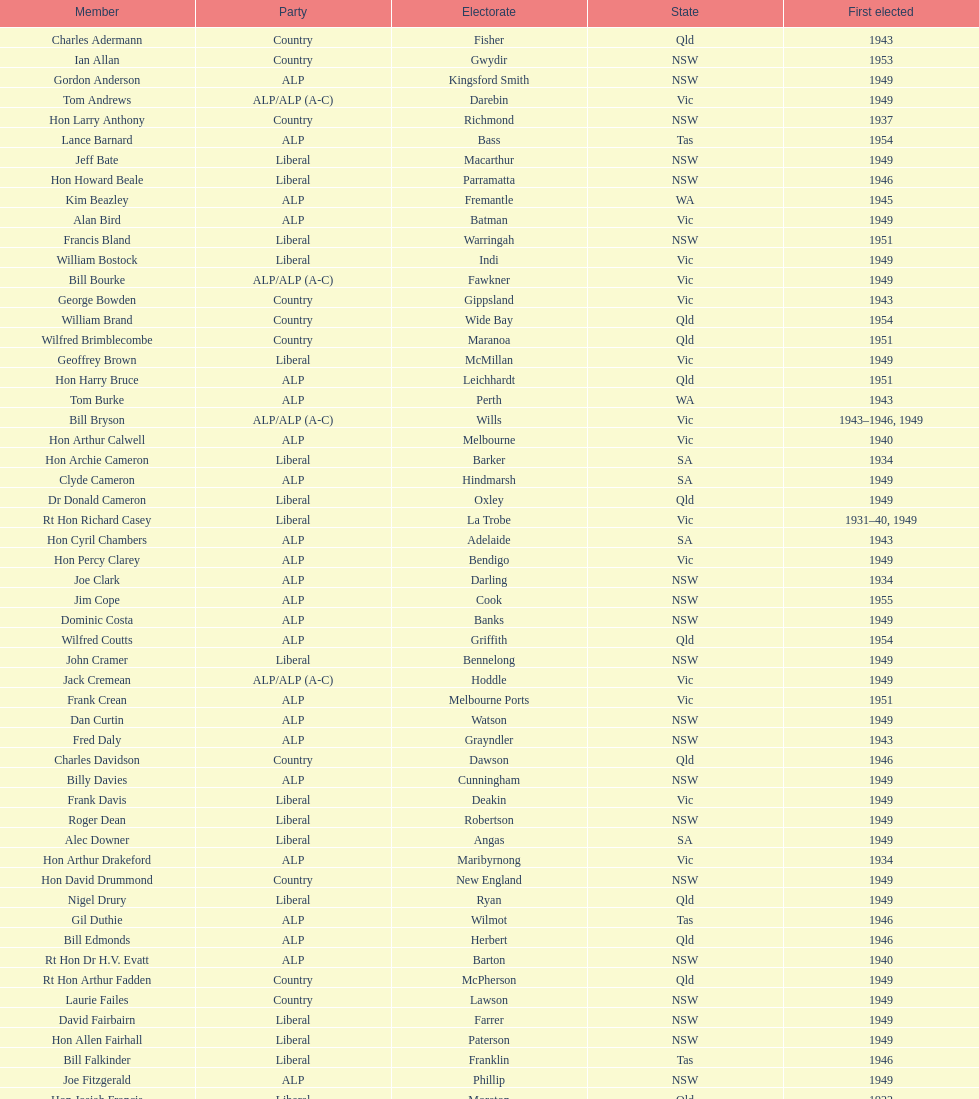Which party was chosen the least? Country. Give me the full table as a dictionary. {'header': ['Member', 'Party', 'Electorate', 'State', 'First elected'], 'rows': [['Charles Adermann', 'Country', 'Fisher', 'Qld', '1943'], ['Ian Allan', 'Country', 'Gwydir', 'NSW', '1953'], ['Gordon Anderson', 'ALP', 'Kingsford Smith', 'NSW', '1949'], ['Tom Andrews', 'ALP/ALP (A-C)', 'Darebin', 'Vic', '1949'], ['Hon Larry Anthony', 'Country', 'Richmond', 'NSW', '1937'], ['Lance Barnard', 'ALP', 'Bass', 'Tas', '1954'], ['Jeff Bate', 'Liberal', 'Macarthur', 'NSW', '1949'], ['Hon Howard Beale', 'Liberal', 'Parramatta', 'NSW', '1946'], ['Kim Beazley', 'ALP', 'Fremantle', 'WA', '1945'], ['Alan Bird', 'ALP', 'Batman', 'Vic', '1949'], ['Francis Bland', 'Liberal', 'Warringah', 'NSW', '1951'], ['William Bostock', 'Liberal', 'Indi', 'Vic', '1949'], ['Bill Bourke', 'ALP/ALP (A-C)', 'Fawkner', 'Vic', '1949'], ['George Bowden', 'Country', 'Gippsland', 'Vic', '1943'], ['William Brand', 'Country', 'Wide Bay', 'Qld', '1954'], ['Wilfred Brimblecombe', 'Country', 'Maranoa', 'Qld', '1951'], ['Geoffrey Brown', 'Liberal', 'McMillan', 'Vic', '1949'], ['Hon Harry Bruce', 'ALP', 'Leichhardt', 'Qld', '1951'], ['Tom Burke', 'ALP', 'Perth', 'WA', '1943'], ['Bill Bryson', 'ALP/ALP (A-C)', 'Wills', 'Vic', '1943–1946, 1949'], ['Hon Arthur Calwell', 'ALP', 'Melbourne', 'Vic', '1940'], ['Hon Archie Cameron', 'Liberal', 'Barker', 'SA', '1934'], ['Clyde Cameron', 'ALP', 'Hindmarsh', 'SA', '1949'], ['Dr Donald Cameron', 'Liberal', 'Oxley', 'Qld', '1949'], ['Rt Hon Richard Casey', 'Liberal', 'La Trobe', 'Vic', '1931–40, 1949'], ['Hon Cyril Chambers', 'ALP', 'Adelaide', 'SA', '1943'], ['Hon Percy Clarey', 'ALP', 'Bendigo', 'Vic', '1949'], ['Joe Clark', 'ALP', 'Darling', 'NSW', '1934'], ['Jim Cope', 'ALP', 'Cook', 'NSW', '1955'], ['Dominic Costa', 'ALP', 'Banks', 'NSW', '1949'], ['Wilfred Coutts', 'ALP', 'Griffith', 'Qld', '1954'], ['John Cramer', 'Liberal', 'Bennelong', 'NSW', '1949'], ['Jack Cremean', 'ALP/ALP (A-C)', 'Hoddle', 'Vic', '1949'], ['Frank Crean', 'ALP', 'Melbourne Ports', 'Vic', '1951'], ['Dan Curtin', 'ALP', 'Watson', 'NSW', '1949'], ['Fred Daly', 'ALP', 'Grayndler', 'NSW', '1943'], ['Charles Davidson', 'Country', 'Dawson', 'Qld', '1946'], ['Billy Davies', 'ALP', 'Cunningham', 'NSW', '1949'], ['Frank Davis', 'Liberal', 'Deakin', 'Vic', '1949'], ['Roger Dean', 'Liberal', 'Robertson', 'NSW', '1949'], ['Alec Downer', 'Liberal', 'Angas', 'SA', '1949'], ['Hon Arthur Drakeford', 'ALP', 'Maribyrnong', 'Vic', '1934'], ['Hon David Drummond', 'Country', 'New England', 'NSW', '1949'], ['Nigel Drury', 'Liberal', 'Ryan', 'Qld', '1949'], ['Gil Duthie', 'ALP', 'Wilmot', 'Tas', '1946'], ['Bill Edmonds', 'ALP', 'Herbert', 'Qld', '1946'], ['Rt Hon Dr H.V. Evatt', 'ALP', 'Barton', 'NSW', '1940'], ['Rt Hon Arthur Fadden', 'Country', 'McPherson', 'Qld', '1949'], ['Laurie Failes', 'Country', 'Lawson', 'NSW', '1949'], ['David Fairbairn', 'Liberal', 'Farrer', 'NSW', '1949'], ['Hon Allen Fairhall', 'Liberal', 'Paterson', 'NSW', '1949'], ['Bill Falkinder', 'Liberal', 'Franklin', 'Tas', '1946'], ['Joe Fitzgerald', 'ALP', 'Phillip', 'NSW', '1949'], ['Hon Josiah Francis', 'Liberal', 'Moreton', 'Qld', '1922'], ['Allan Fraser', 'ALP', 'Eden-Monaro', 'NSW', '1943'], ['Jim Fraser', 'ALP', 'Australian Capital Territory', 'ACT', '1951'], ['Gordon Freeth', 'Liberal', 'Forrest', 'WA', '1949'], ['Arthur Fuller', 'Country', 'Hume', 'NSW', '1943–49, 1951'], ['Pat Galvin', 'ALP', 'Kingston', 'SA', '1951'], ['Arthur Greenup', 'ALP', 'Dalley', 'NSW', '1953'], ['Charles Griffiths', 'ALP', 'Shortland', 'NSW', '1949'], ['Jo Gullett', 'Liberal', 'Henty', 'Vic', '1946'], ['Len Hamilton', 'Country', 'Canning', 'WA', '1946'], ['Rt Hon Eric Harrison', 'Liberal', 'Wentworth', 'NSW', '1931'], ['Jim Harrison', 'ALP', 'Blaxland', 'NSW', '1949'], ['Hon Paul Hasluck', 'Liberal', 'Curtin', 'WA', '1949'], ['Hon William Haworth', 'Liberal', 'Isaacs', 'Vic', '1949'], ['Leslie Haylen', 'ALP', 'Parkes', 'NSW', '1943'], ['Rt Hon Harold Holt', 'Liberal', 'Higgins', 'Vic', '1935'], ['John Howse', 'Liberal', 'Calare', 'NSW', '1946'], ['Alan Hulme', 'Liberal', 'Petrie', 'Qld', '1949'], ['William Jack', 'Liberal', 'North Sydney', 'NSW', '1949'], ['Rowley James', 'ALP', 'Hunter', 'NSW', '1928'], ['Hon Herbert Johnson', 'ALP', 'Kalgoorlie', 'WA', '1940'], ['Bob Joshua', 'ALP/ALP (A-C)', 'Ballaarat', 'ALP', '1951'], ['Percy Joske', 'Liberal', 'Balaclava', 'Vic', '1951'], ['Hon Wilfrid Kent Hughes', 'Liberal', 'Chisholm', 'Vic', '1949'], ['Stan Keon', 'ALP/ALP (A-C)', 'Yarra', 'Vic', '1949'], ['William Lawrence', 'Liberal', 'Wimmera', 'Vic', '1949'], ['Hon George Lawson', 'ALP', 'Brisbane', 'Qld', '1931'], ['Nelson Lemmon', 'ALP', 'St George', 'NSW', '1943–49, 1954'], ['Hugh Leslie', 'Liberal', 'Moore', 'Country', '1949'], ['Robert Lindsay', 'Liberal', 'Flinders', 'Vic', '1954'], ['Tony Luchetti', 'ALP', 'Macquarie', 'NSW', '1951'], ['Aubrey Luck', 'Liberal', 'Darwin', 'Tas', '1951'], ['Philip Lucock', 'Country', 'Lyne', 'NSW', '1953'], ['Dan Mackinnon', 'Liberal', 'Corangamite', 'Vic', '1949–51, 1953'], ['Hon Norman Makin', 'ALP', 'Sturt', 'SA', '1919–46, 1954'], ['Hon Philip McBride', 'Liberal', 'Wakefield', 'SA', '1931–37, 1937–43 (S), 1946'], ['Malcolm McColm', 'Liberal', 'Bowman', 'Qld', '1949'], ['Rt Hon John McEwen', 'Country', 'Murray', 'Vic', '1934'], ['John McLeay', 'Liberal', 'Boothby', 'SA', '1949'], ['Don McLeod', 'Liberal', 'Wannon', 'ALP', '1940–49, 1951'], ['Hon William McMahon', 'Liberal', 'Lowe', 'NSW', '1949'], ['Rt Hon Robert Menzies', 'Liberal', 'Kooyong', 'Vic', '1934'], ['Dan Minogue', 'ALP', 'West Sydney', 'NSW', '1949'], ['Charles Morgan', 'ALP', 'Reid', 'NSW', '1940–46, 1949'], ['Jack Mullens', 'ALP/ALP (A-C)', 'Gellibrand', 'Vic', '1949'], ['Jock Nelson', 'ALP', 'Northern Territory', 'NT', '1949'], ["William O'Connor", 'ALP', 'Martin', 'NSW', '1946'], ['Hubert Opperman', 'Liberal', 'Corio', 'Vic', '1949'], ['Hon Frederick Osborne', 'Liberal', 'Evans', 'NSW', '1949'], ['Rt Hon Sir Earle Page', 'Country', 'Cowper', 'NSW', '1919'], ['Henry Pearce', 'Liberal', 'Capricornia', 'Qld', '1949'], ['Ted Peters', 'ALP', 'Burke', 'Vic', '1949'], ['Hon Reg Pollard', 'ALP', 'Lalor', 'Vic', '1937'], ['Hon Bill Riordan', 'ALP', 'Kennedy', 'Qld', '1936'], ['Hugh Roberton', 'Country', 'Riverina', 'NSW', '1949'], ['Edgar Russell', 'ALP', 'Grey', 'SA', '1943'], ['Tom Sheehan', 'ALP', 'Cook', 'NSW', '1937'], ['Frank Stewart', 'ALP', 'Lang', 'NSW', '1953'], ['Reginald Swartz', 'Liberal', 'Darling Downs', 'Qld', '1949'], ['Albert Thompson', 'ALP', 'Port Adelaide', 'SA', '1946'], ['Frank Timson', 'Liberal', 'Higinbotham', 'Vic', '1949'], ['Hon Athol Townley', 'Liberal', 'Denison', 'Tas', '1949'], ['Winton Turnbull', 'Country', 'Mallee', 'Vic', '1946'], ['Harry Turner', 'Liberal', 'Bradfield', 'NSW', '1952'], ['Hon Eddie Ward', 'ALP', 'East Sydney', 'NSW', '1931, 1932'], ['David Oliver Watkins', 'ALP', 'Newcastle', 'NSW', '1935'], ['Harry Webb', 'ALP', 'Swan', 'WA', '1954'], ['William Wentworth', 'Liberal', 'Mackellar', 'NSW', '1949'], ['Roy Wheeler', 'Liberal', 'Mitchell', 'NSW', '1949'], ['Gough Whitlam', 'ALP', 'Werriwa', 'NSW', '1952'], ['Bruce Wight', 'Liberal', 'Lilley', 'Qld', '1949']]} 